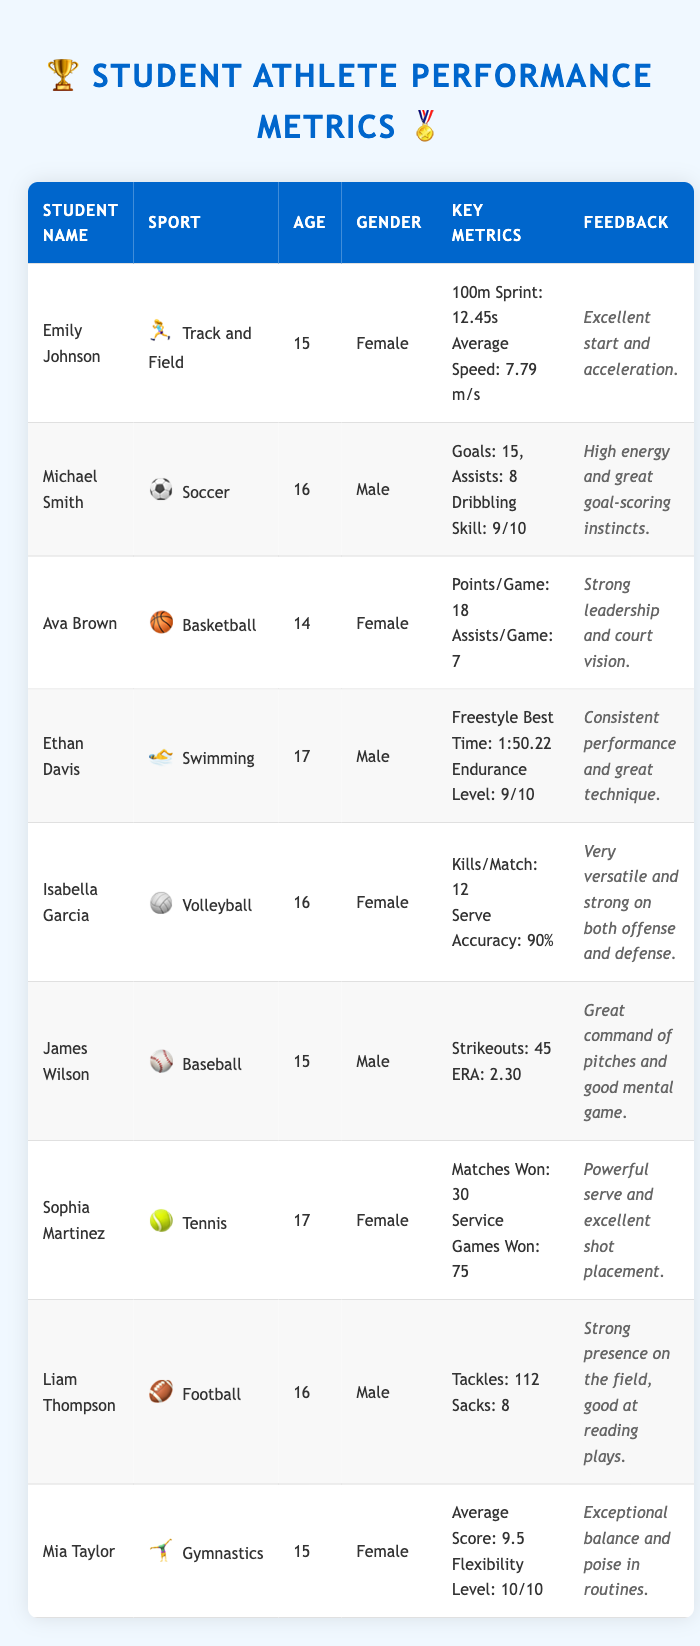What is Emily Johnson's best time in the 100m Sprint? According to the table, Emily Johnson's Personal Best Time in the 100m Sprint is listed as "12.45s."
Answer: 12.45s How many goals did Michael Smith score in the season? The table states that Michael Smith scored a total of 15 goals in the season.
Answer: 15 goals Who has the highest average score in gymnastics? Mia Taylor has an Average Score of 9.5 in gymnastics, which is higher than others listed in the table.
Answer: Mia Taylor What is the combined total of goals and assists for Michael Smith? To find the combined total, we add Goals Scored (15) and Assists (8): 15 + 8 = 23.
Answer: 23 Is Ava Brown's shooting percentage over 40%? According to the table, Ava Brown has a Shooting Percentage of "45%," which is indeed over 40%.
Answer: Yes Which athlete has the best Endurance Level? In the table, Ethan Davis has an Endurance Level of 9, which is the highest among all listed athletes.
Answer: Ethan Davis What is the difference in Average Score between Mia Taylor and the highest scorer in Tennis? Mia Taylor's Average Score is 9.5, while Sophia Martinez won 30 matches. Since match wins are not scored similarly, we do not have a direct average comparison. Instead, checking the average score of gymnasts directly is better, where Mia has no other counterpart listed. Therefore, the difference cannot be computed in this context.
Answer: Cannot be computed How many assists does Liam Thompson have? The table does not provide any assists for Liam Thompson since he plays as a Linebacker in Football, and assists are typically not listed for that position. Therefore, we can say that the information is not available.
Answer: Not available Which athlete has a perfect flexibility level? Mia Taylor has a Flexibility Level of 10, indicating a perfect score in that area.
Answer: Mia Taylor 